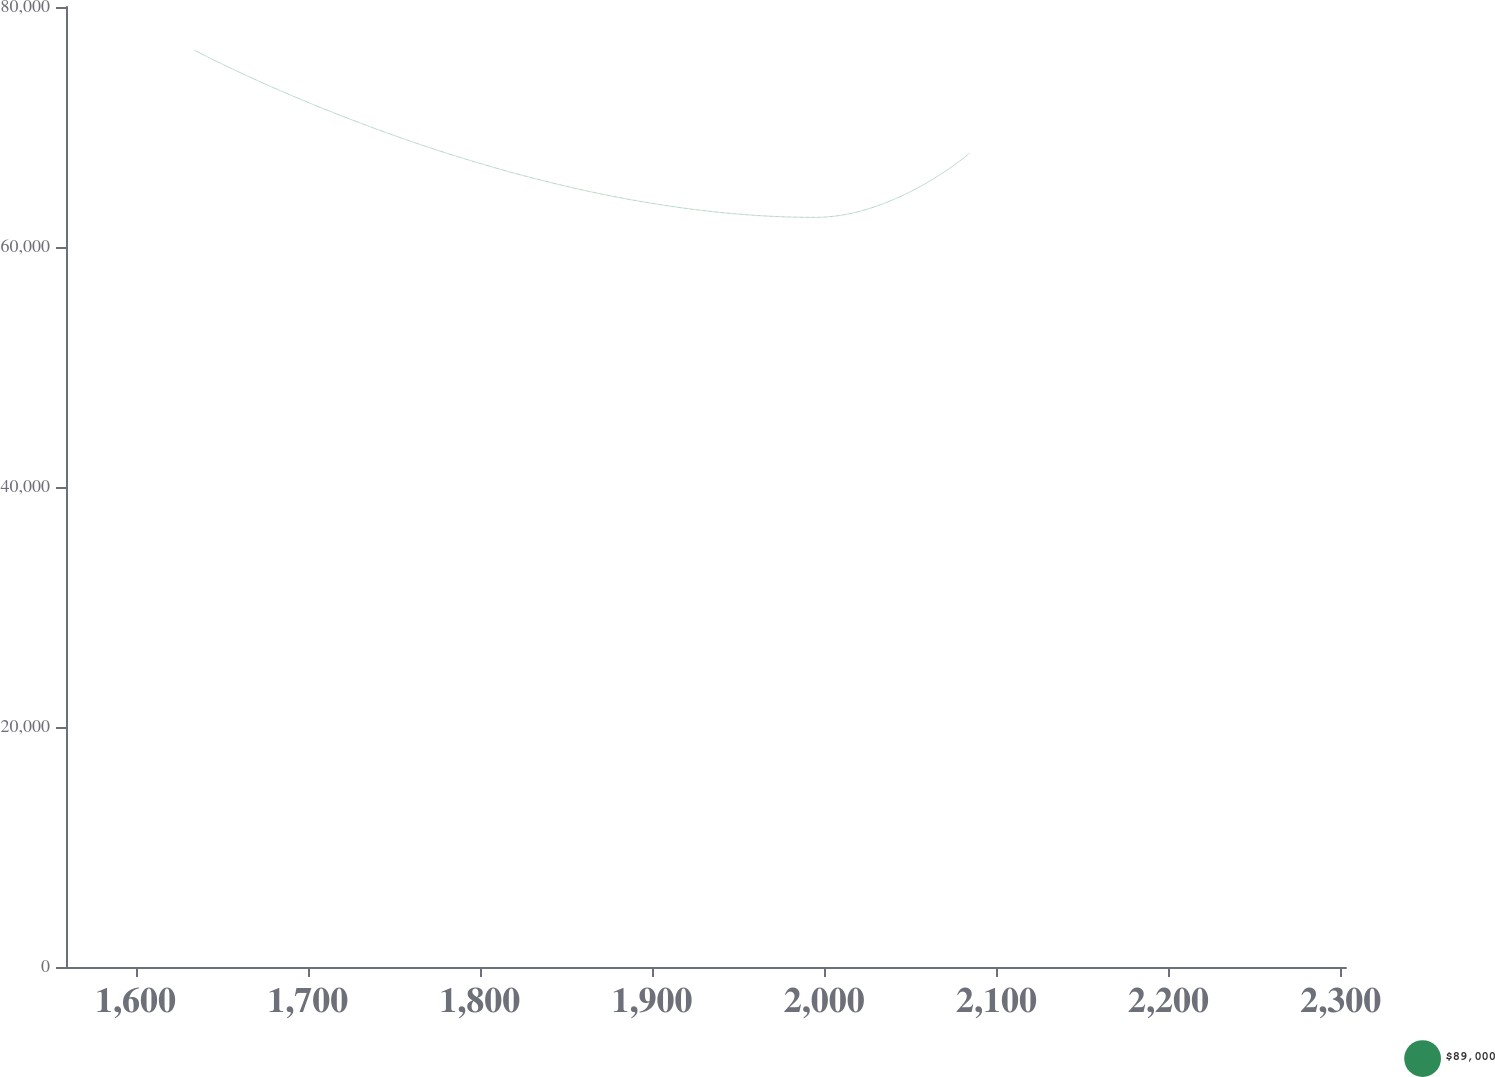Convert chart to OTSL. <chart><loc_0><loc_0><loc_500><loc_500><line_chart><ecel><fcel>$89,000<nl><fcel>1633.97<fcel>76418.1<nl><fcel>1994.69<fcel>62469.4<nl><fcel>2084.54<fcel>67825.1<nl><fcel>2377.4<fcel>63864.3<nl></chart> 